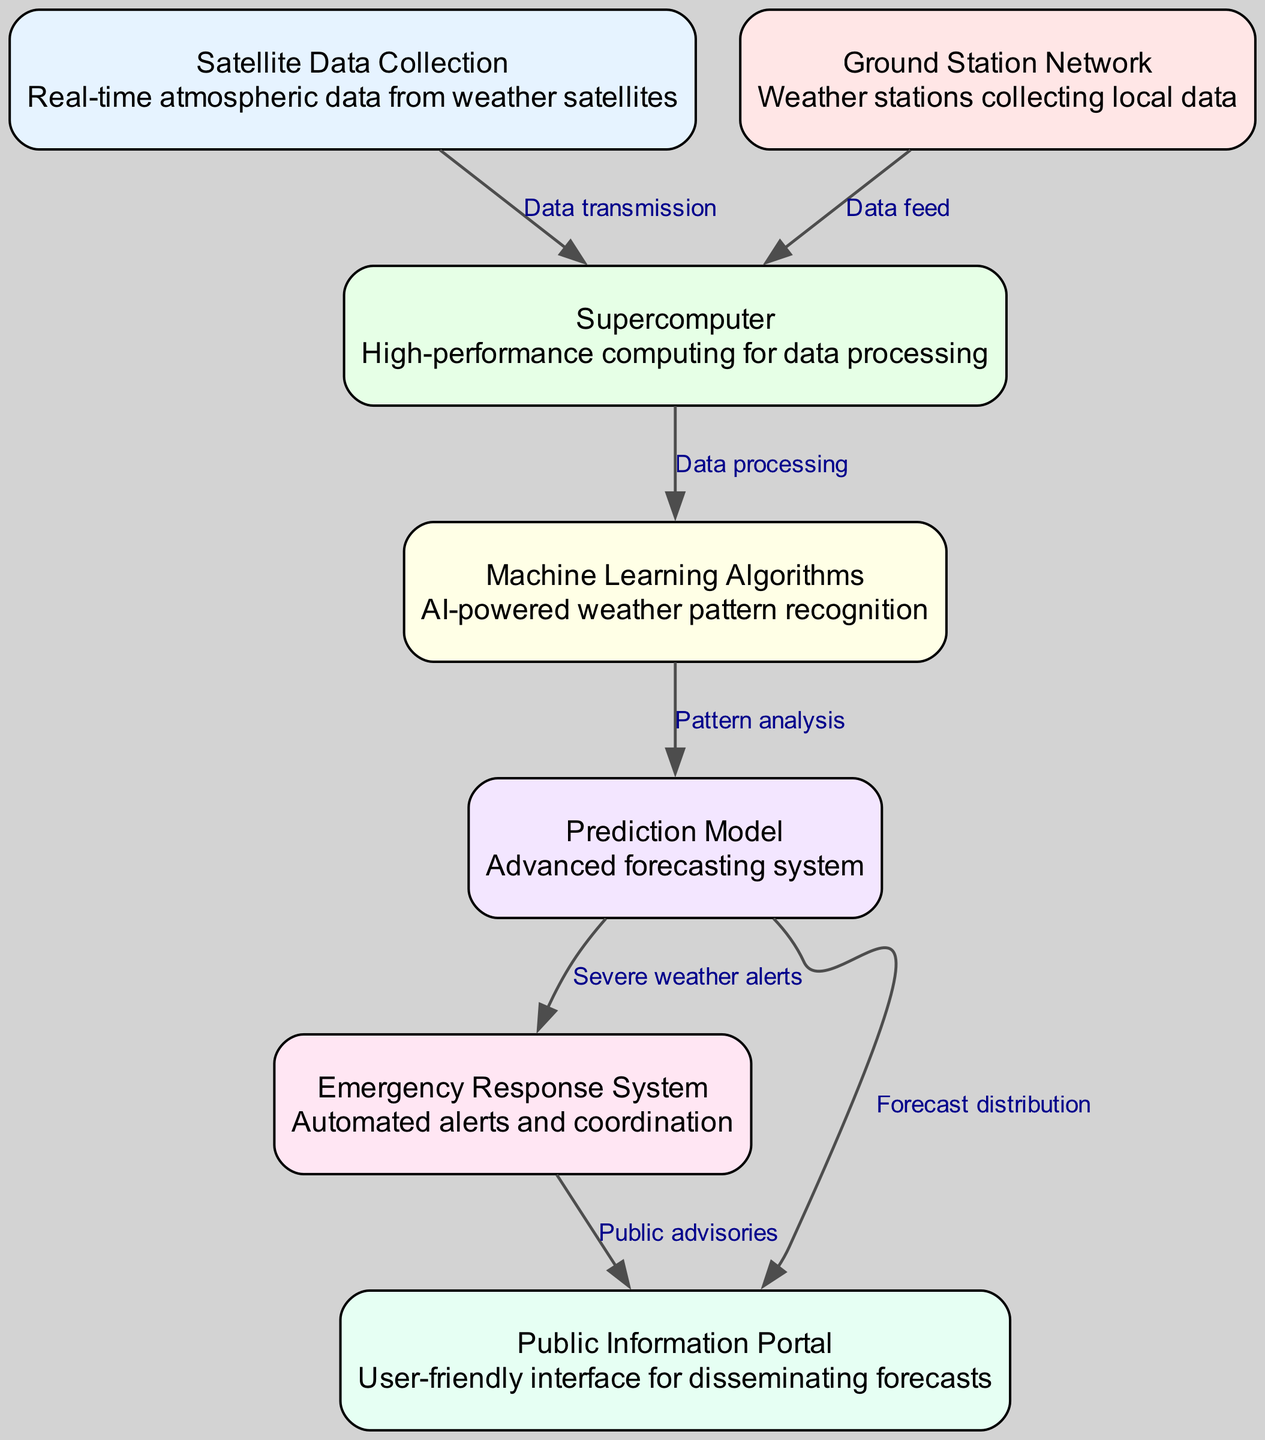What is the total number of nodes in the diagram? The diagram lists 7 distinct nodes, indicating different components of the weather prediction system. Counting each individual node in the provided data shows that the number is 7.
Answer: 7 What type of data is collected in the "Satellite Data Collection" node? The description of the "Satellite Data Collection" node states it collects real-time atmospheric data from weather satellites, indicating that the primary focus is on atmospheric data.
Answer: Atmospheric data What is the relationship between the "Prediction Model" and the "Emergency Response System"? The "Prediction Model" node indicates that it sends severe weather alerts directly to the "Emergency Response System," establishing a directional connection that facilitates alerting for severe conditions.
Answer: Severe weather alerts How many edges connect the "Public Information Portal" node? Upon reviewing the edges connected to the "Public Information Portal" node, it shows that there are 2 connections, one from the "Prediction Model" and another from the "Emergency Response System."
Answer: 2 Which node is responsible for data processing? The "Supercomputer" node is explicitly stated as the device that processes data, thus taking input from both the "Satellite Data Collection" and "Ground Station Network" nodes to perform computation.
Answer: Supercomputer What does the "Machine Learning Algorithms" node do? According to its description, this node performs AI-powered weather pattern recognition, which indicates that it uses algorithms to identify trends in the collected weather data.
Answer: Pattern recognition Which node provides a user-friendly interface for disseminating forecasts? The "Public Information Portal" is designated as the node that serves this function, specifically aimed at making forecasts accessible to the public in an intuitive manner.
Answer: Public Information Portal What comes after "Pattern analysis"? The next step in the flow following "Pattern analysis" is the "Prediction Model," which indicates that this component leverages insights derived from pattern recognition to create forecasts.
Answer: Prediction Model What is the purpose of the "Ground Station Network" node? The description for the "Ground Station Network" node states it is responsible for collecting local data, representing an essential data input source for the overall predictive system.
Answer: Collecting local data 